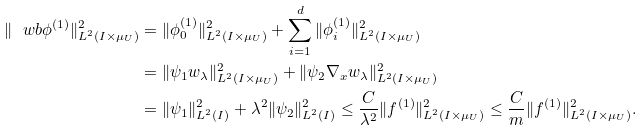<formula> <loc_0><loc_0><loc_500><loc_500>\| \ w b { \phi } ^ { ( 1 ) } \| _ { L ^ { 2 } ( I \times \mu _ { U } ) } ^ { 2 } & = \| \phi _ { 0 } ^ { ( 1 ) } \| _ { L ^ { 2 } ( I \times \mu _ { U } ) } ^ { 2 } + \sum _ { i = 1 } ^ { d } \| \phi _ { i } ^ { ( 1 ) } \| _ { L ^ { 2 } ( I \times \mu _ { U } ) } ^ { 2 } \\ & = \| \psi _ { 1 } w _ { \lambda } \| _ { L ^ { 2 } ( I \times \mu _ { U } ) } ^ { 2 } + \| \psi _ { 2 } \nabla _ { x } w _ { \lambda } \| _ { L ^ { 2 } ( I \times \mu _ { U } ) } ^ { 2 } \\ & = \| \psi _ { 1 } \| _ { L ^ { 2 } ( I ) } ^ { 2 } + \lambda ^ { 2 } \| \psi _ { 2 } \| _ { L ^ { 2 } ( I ) } ^ { 2 } \leq \frac { C } { \lambda ^ { 2 } } \| f ^ { ( 1 ) } \| _ { L ^ { 2 } ( I \times \mu _ { U } ) } ^ { 2 } \leq \frac { C } { m } \| f ^ { ( 1 ) } \| _ { L ^ { 2 } ( I \times \mu _ { U } ) } ^ { 2 } .</formula> 